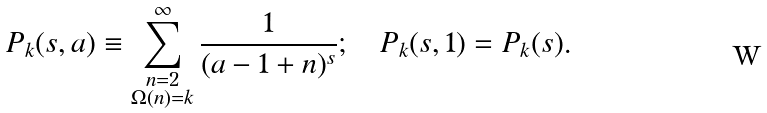<formula> <loc_0><loc_0><loc_500><loc_500>P _ { k } ( s , a ) \equiv \sum _ { \substack { n = 2 \\ \Omega ( n ) = k } } ^ { \infty } \frac { 1 } { ( a - 1 + n ) ^ { s } } ; \quad P _ { k } ( s , 1 ) = P _ { k } ( s ) .</formula> 